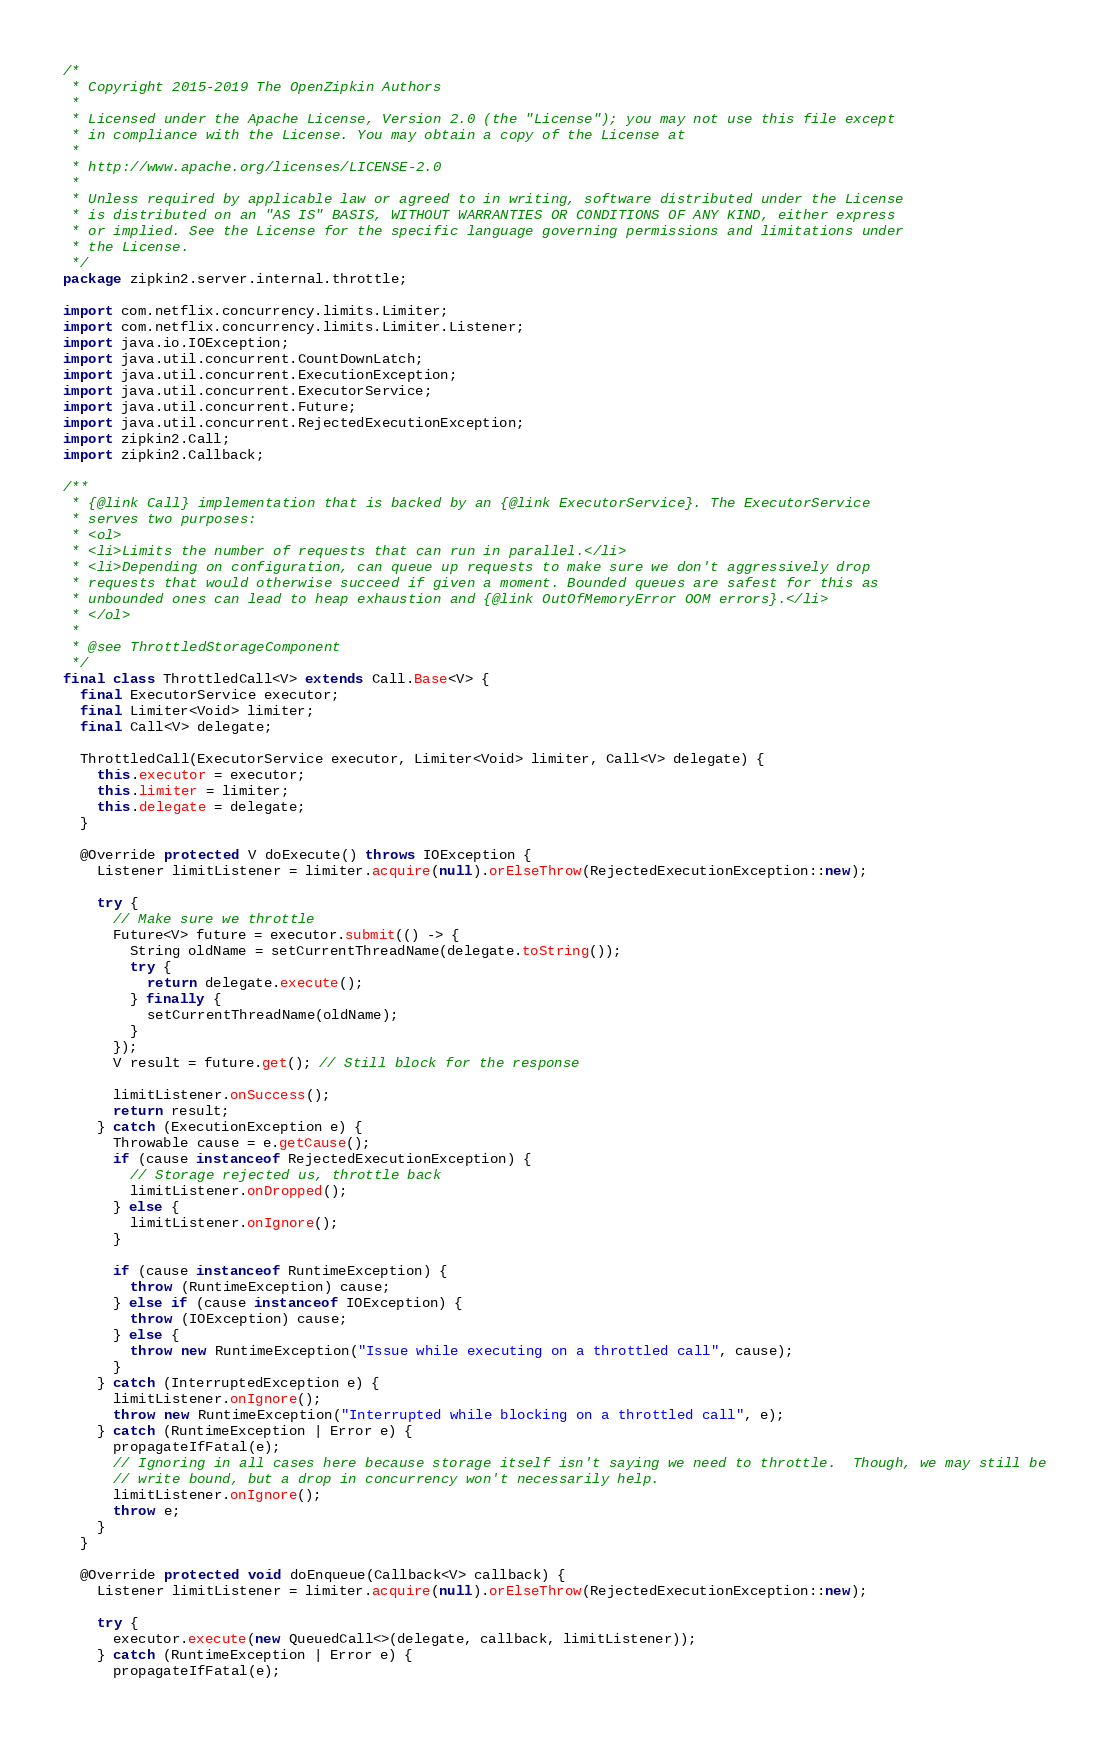<code> <loc_0><loc_0><loc_500><loc_500><_Java_>/*
 * Copyright 2015-2019 The OpenZipkin Authors
 *
 * Licensed under the Apache License, Version 2.0 (the "License"); you may not use this file except
 * in compliance with the License. You may obtain a copy of the License at
 *
 * http://www.apache.org/licenses/LICENSE-2.0
 *
 * Unless required by applicable law or agreed to in writing, software distributed under the License
 * is distributed on an "AS IS" BASIS, WITHOUT WARRANTIES OR CONDITIONS OF ANY KIND, either express
 * or implied. See the License for the specific language governing permissions and limitations under
 * the License.
 */
package zipkin2.server.internal.throttle;

import com.netflix.concurrency.limits.Limiter;
import com.netflix.concurrency.limits.Limiter.Listener;
import java.io.IOException;
import java.util.concurrent.CountDownLatch;
import java.util.concurrent.ExecutionException;
import java.util.concurrent.ExecutorService;
import java.util.concurrent.Future;
import java.util.concurrent.RejectedExecutionException;
import zipkin2.Call;
import zipkin2.Callback;

/**
 * {@link Call} implementation that is backed by an {@link ExecutorService}. The ExecutorService
 * serves two purposes:
 * <ol>
 * <li>Limits the number of requests that can run in parallel.</li>
 * <li>Depending on configuration, can queue up requests to make sure we don't aggressively drop
 * requests that would otherwise succeed if given a moment. Bounded queues are safest for this as
 * unbounded ones can lead to heap exhaustion and {@link OutOfMemoryError OOM errors}.</li>
 * </ol>
 *
 * @see ThrottledStorageComponent
 */
final class ThrottledCall<V> extends Call.Base<V> {
  final ExecutorService executor;
  final Limiter<Void> limiter;
  final Call<V> delegate;

  ThrottledCall(ExecutorService executor, Limiter<Void> limiter, Call<V> delegate) {
    this.executor = executor;
    this.limiter = limiter;
    this.delegate = delegate;
  }

  @Override protected V doExecute() throws IOException {
    Listener limitListener = limiter.acquire(null).orElseThrow(RejectedExecutionException::new);

    try {
      // Make sure we throttle
      Future<V> future = executor.submit(() -> {
        String oldName = setCurrentThreadName(delegate.toString());
        try {
          return delegate.execute();
        } finally {
          setCurrentThreadName(oldName);
        }
      });
      V result = future.get(); // Still block for the response

      limitListener.onSuccess();
      return result;
    } catch (ExecutionException e) {
      Throwable cause = e.getCause();
      if (cause instanceof RejectedExecutionException) {
        // Storage rejected us, throttle back
        limitListener.onDropped();
      } else {
        limitListener.onIgnore();
      }

      if (cause instanceof RuntimeException) {
        throw (RuntimeException) cause;
      } else if (cause instanceof IOException) {
        throw (IOException) cause;
      } else {
        throw new RuntimeException("Issue while executing on a throttled call", cause);
      }
    } catch (InterruptedException e) {
      limitListener.onIgnore();
      throw new RuntimeException("Interrupted while blocking on a throttled call", e);
    } catch (RuntimeException | Error e) {
      propagateIfFatal(e);
      // Ignoring in all cases here because storage itself isn't saying we need to throttle.  Though, we may still be
      // write bound, but a drop in concurrency won't necessarily help.
      limitListener.onIgnore();
      throw e;
    }
  }

  @Override protected void doEnqueue(Callback<V> callback) {
    Listener limitListener = limiter.acquire(null).orElseThrow(RejectedExecutionException::new);

    try {
      executor.execute(new QueuedCall<>(delegate, callback, limitListener));
    } catch (RuntimeException | Error e) {
      propagateIfFatal(e);</code> 